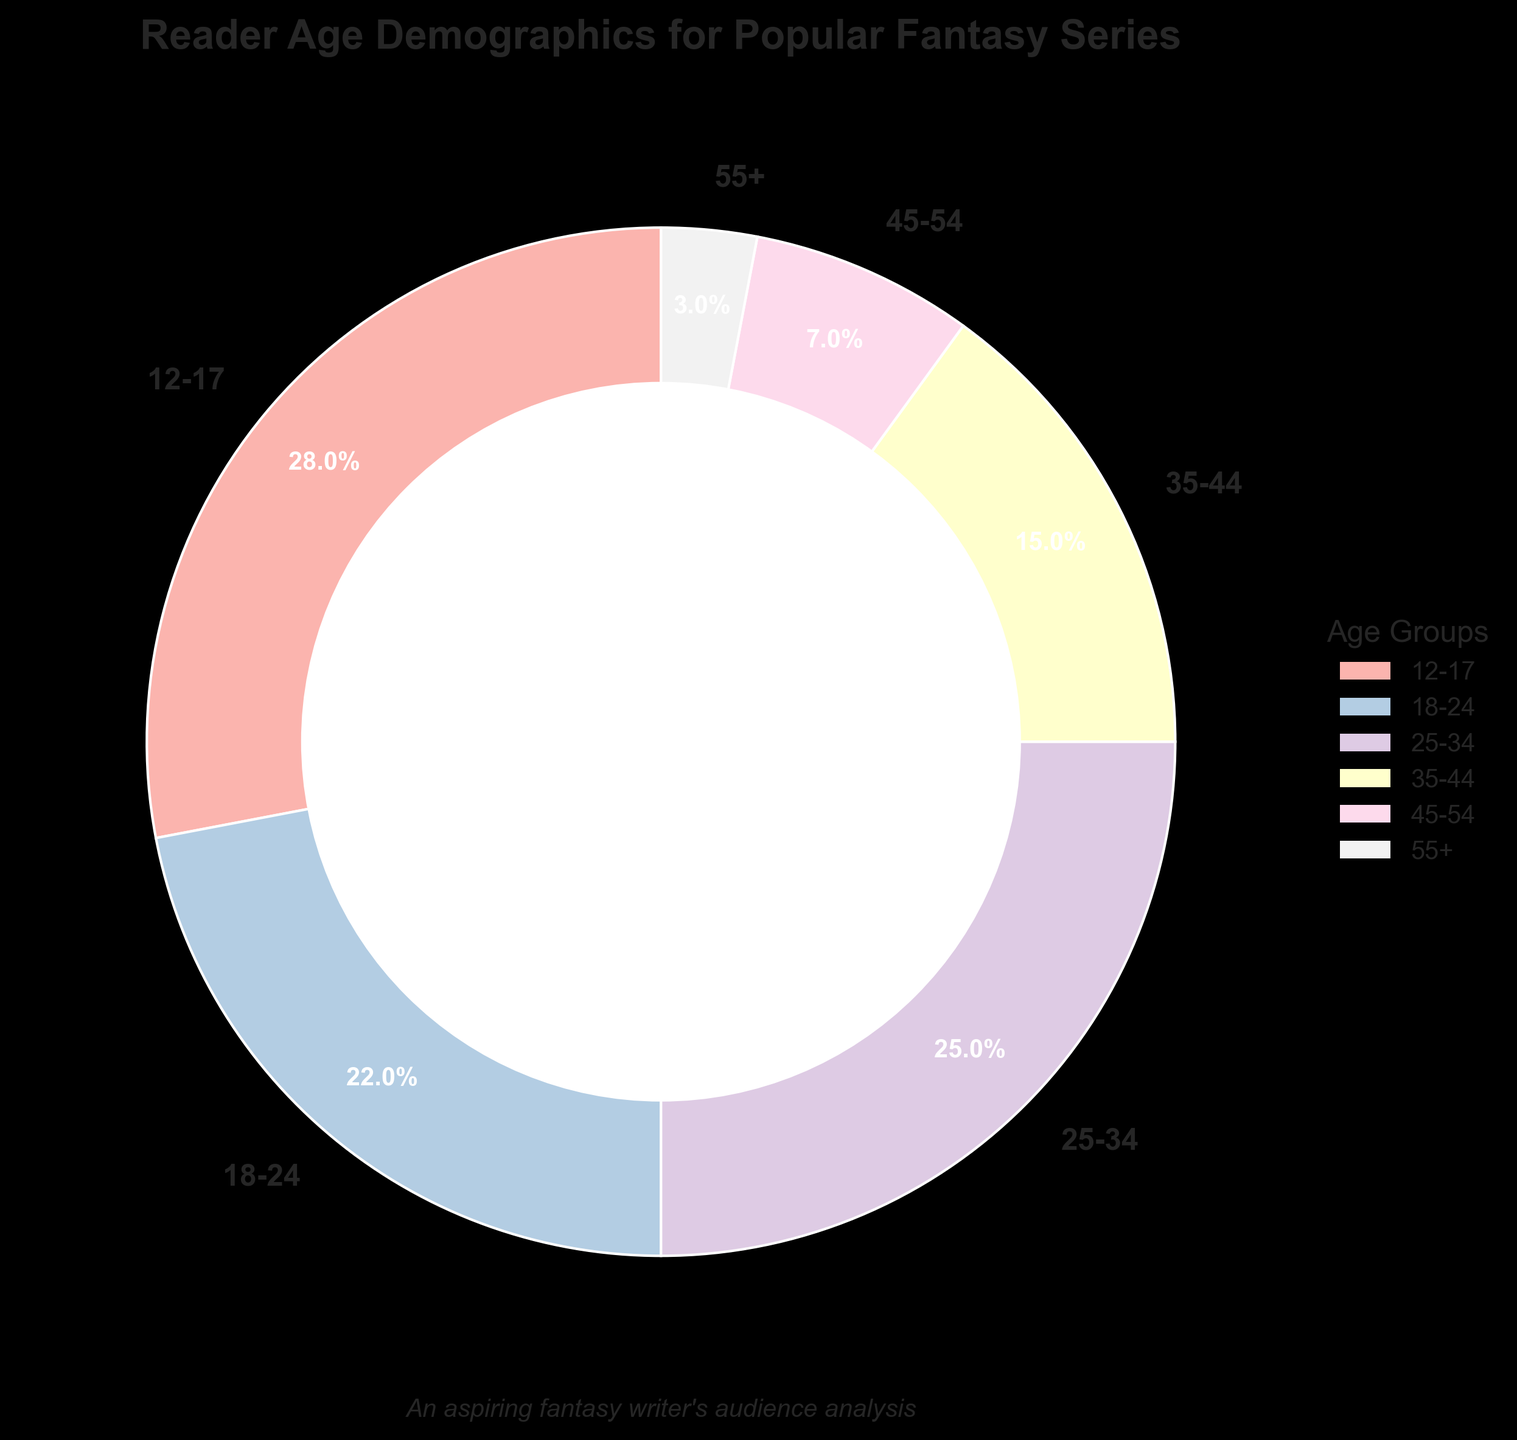Which age group has the highest percentage of readers? Looking at the pie chart, the largest section represents ages 12-17. This section is also highlighted with the largest percentage label of 28%.
Answer: 12-17 What is the combined percentage of readers aged 25-34 and 35-44? Sum the percentages of the age groups 25-34 and 35-44: 25% + 15% = 40%.
Answer: 40% Which age group has the smallest representation in the readership? The smallest slice of the pie chart corresponds to the 55+ age group, labeled with a percentage of 3%.
Answer: 55+ How does the percentage of readers aged 18-24 compare to those aged 45-54? The percentage of readers aged 18-24 is 22%, which is higher compared to the 7% of readers aged 45-54.
Answer: 18-24 has a higher percentage Is the percentage of readers under 18 greater than those over 44? Add the percentages of age groups 12-17 and compare to the sum of age groups 45-54 and 55+. So, 28% > (7% + 3%).
Answer: Yes Which age groups together make up over 50% of the readership? Sum the largest percentages until it exceeds 50%. 12-17 (28%) + 18-24 (22%) = 50%. Thus, readers aged 12-17 and 18-24 together make 50% of the readership.
Answer: 12-17 and 18-24 What is the difference in the percentage of readers between the age groups 35-44 and 45-54? Subtract the percentage for age group 45-54 from 35-44: 15% - 7% = 8%.
Answer: 8% Which two age groups have the closest percentage of readers? Comparing all age groups, the percentages of age groups 18-24 (22%) and 25-34 (25%) have the closest values.
Answer: 18-24 and 25-34 What is the combined percentage of the two least represented age groups? Combine the percentages of age groups 55+ (3%) and 45-54 (7%): 3% + 7% = 10%.
Answer: 10% 